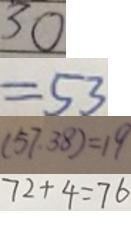Convert formula to latex. <formula><loc_0><loc_0><loc_500><loc_500>3 0 
 = 5 3 
 ( 5 7 , 3 8 ) = 1 9 
 7 2 + 4 = 7 6</formula> 